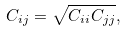Convert formula to latex. <formula><loc_0><loc_0><loc_500><loc_500>C _ { i j } = \sqrt { C _ { i i } C _ { j j } } ,</formula> 